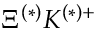<formula> <loc_0><loc_0><loc_500><loc_500>\Xi ^ { ( * ) } K ^ { ( * ) + }</formula> 